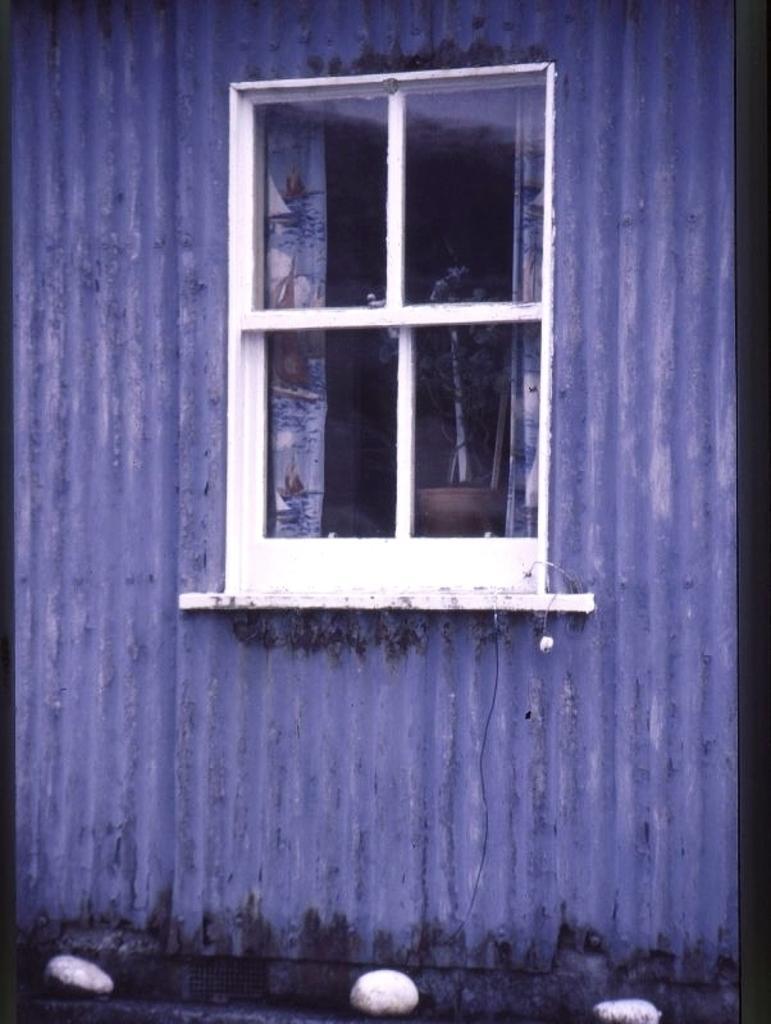Could you give a brief overview of what you see in this image? This picture shows a window, from the window we see a plant in the pot and curtains to the window and we see stones on the floor. 